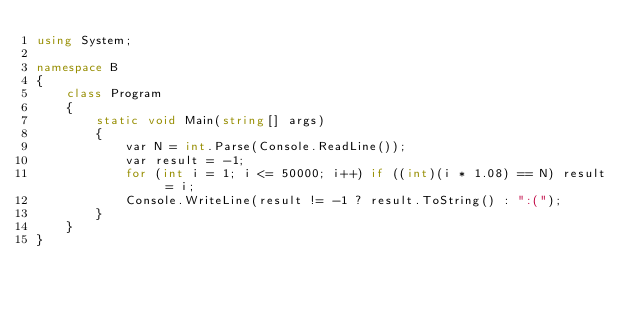<code> <loc_0><loc_0><loc_500><loc_500><_C#_>using System;

namespace B
{
    class Program
    {
        static void Main(string[] args)
        {
            var N = int.Parse(Console.ReadLine());
            var result = -1;
            for (int i = 1; i <= 50000; i++) if ((int)(i * 1.08) == N) result = i;
            Console.WriteLine(result != -1 ? result.ToString() : ":(");
        }
    }
}
</code> 